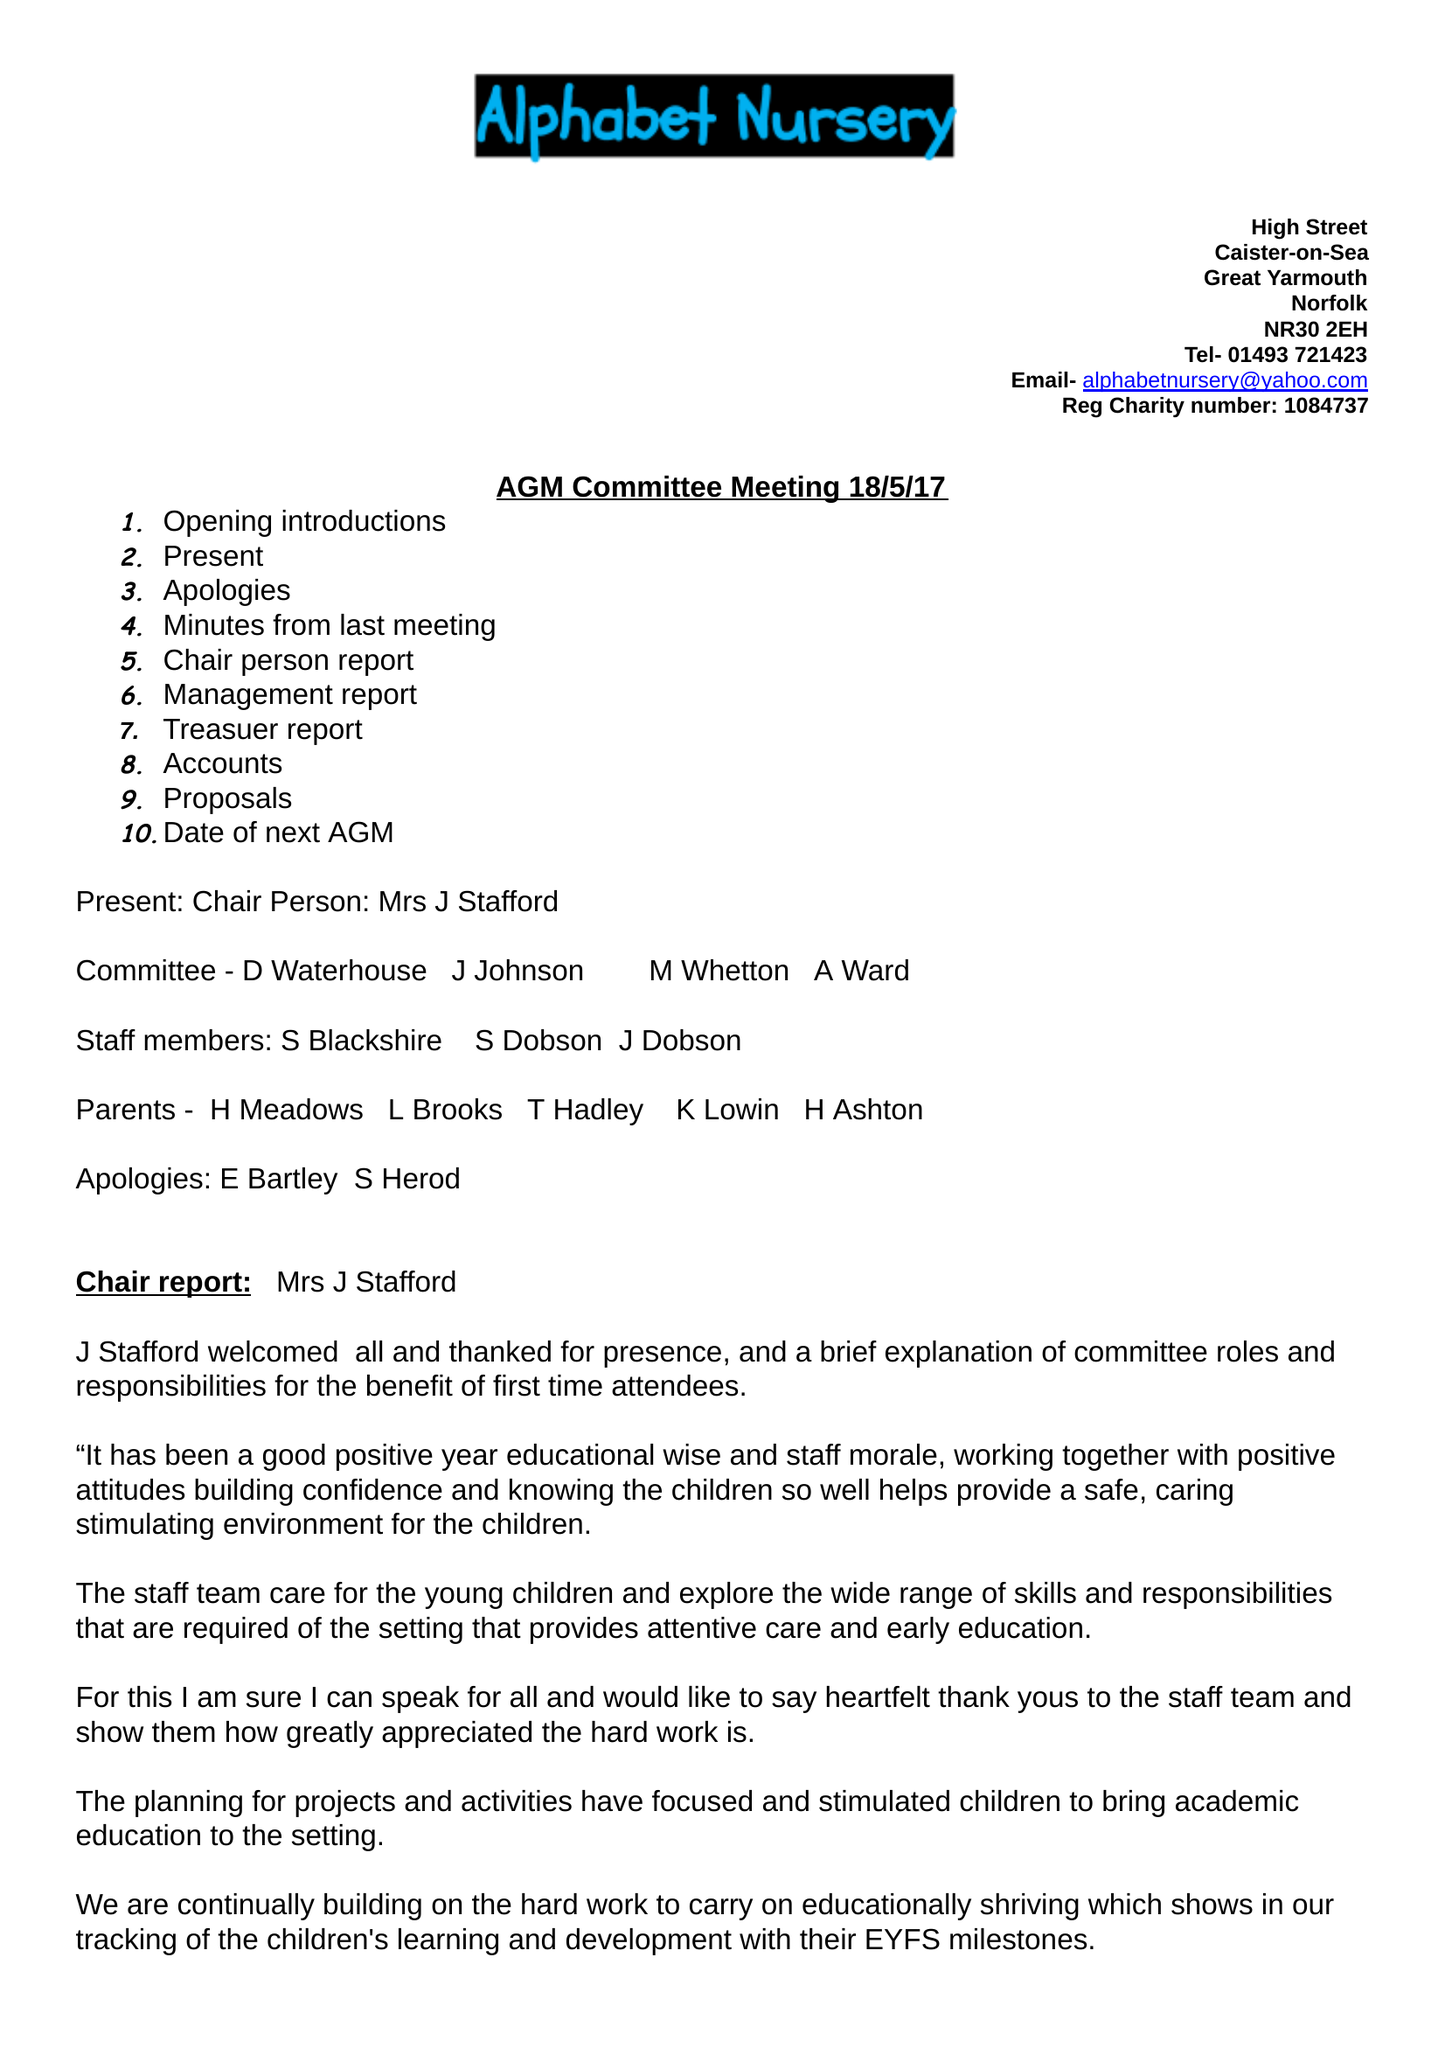What is the value for the charity_name?
Answer the question using a single word or phrase. Alphabet Nursery 